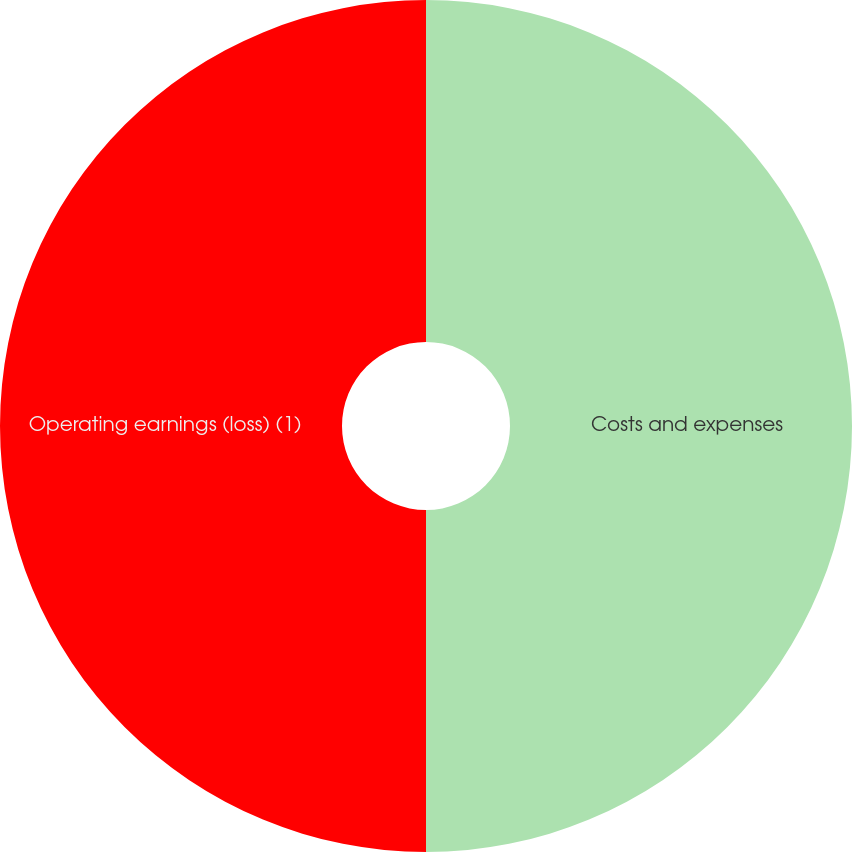<chart> <loc_0><loc_0><loc_500><loc_500><pie_chart><fcel>Costs and expenses<fcel>Operating earnings (loss) (1)<nl><fcel>50.0%<fcel>50.0%<nl></chart> 